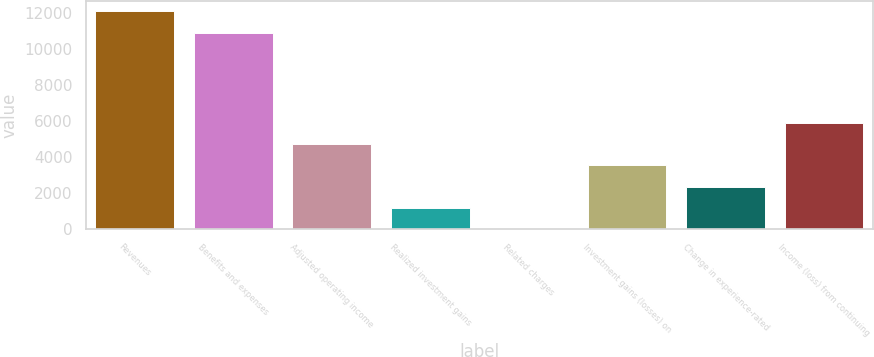<chart> <loc_0><loc_0><loc_500><loc_500><bar_chart><fcel>Revenues<fcel>Benefits and expenses<fcel>Adjusted operating income<fcel>Realized investment gains<fcel>Related charges<fcel>Investment gains (losses) on<fcel>Change in experience-rated<fcel>Income (loss) from continuing<nl><fcel>12072<fcel>10890<fcel>4729<fcel>1183<fcel>1<fcel>3547<fcel>2365<fcel>5911<nl></chart> 